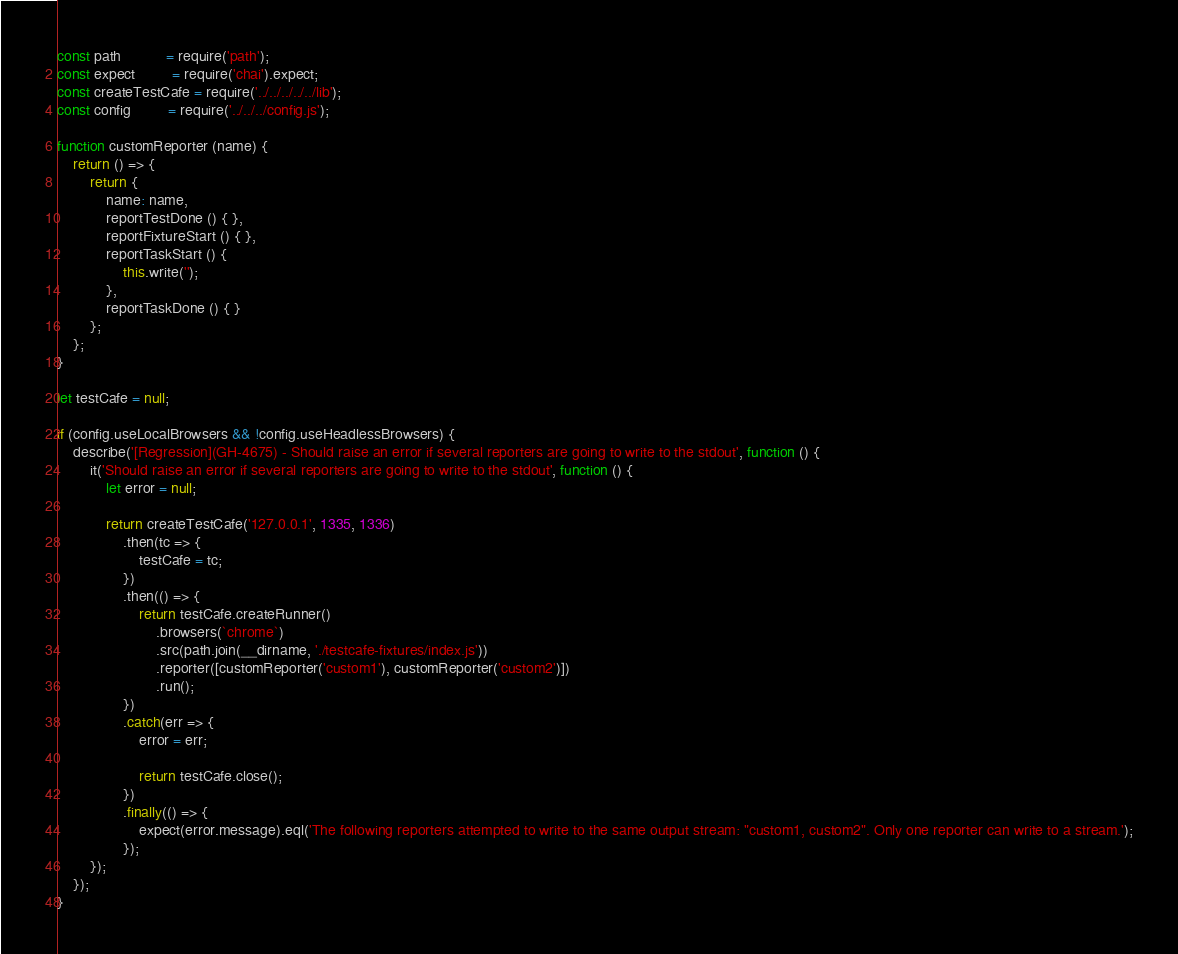<code> <loc_0><loc_0><loc_500><loc_500><_JavaScript_>const path           = require('path');
const expect         = require('chai').expect;
const createTestCafe = require('../../../../../lib');
const config         = require('../../../config.js');

function customReporter (name) {
    return () => {
        return {
            name: name,
            reportTestDone () { },
            reportFixtureStart () { },
            reportTaskStart () {
                this.write('');
            },
            reportTaskDone () { }
        };
    };
}

let testCafe = null;

if (config.useLocalBrowsers && !config.useHeadlessBrowsers) {
    describe('[Regression](GH-4675) - Should raise an error if several reporters are going to write to the stdout', function () {
        it('Should raise an error if several reporters are going to write to the stdout', function () {
            let error = null;

            return createTestCafe('127.0.0.1', 1335, 1336)
                .then(tc => {
                    testCafe = tc;
                })
                .then(() => {
                    return testCafe.createRunner()
                        .browsers(`chrome`)
                        .src(path.join(__dirname, './testcafe-fixtures/index.js'))
                        .reporter([customReporter('custom1'), customReporter('custom2')])
                        .run();
                })
                .catch(err => {
                    error = err;

                    return testCafe.close();
                })
                .finally(() => {
                    expect(error.message).eql('The following reporters attempted to write to the same output stream: "custom1, custom2". Only one reporter can write to a stream.');
                });
        });
    });
}
</code> 